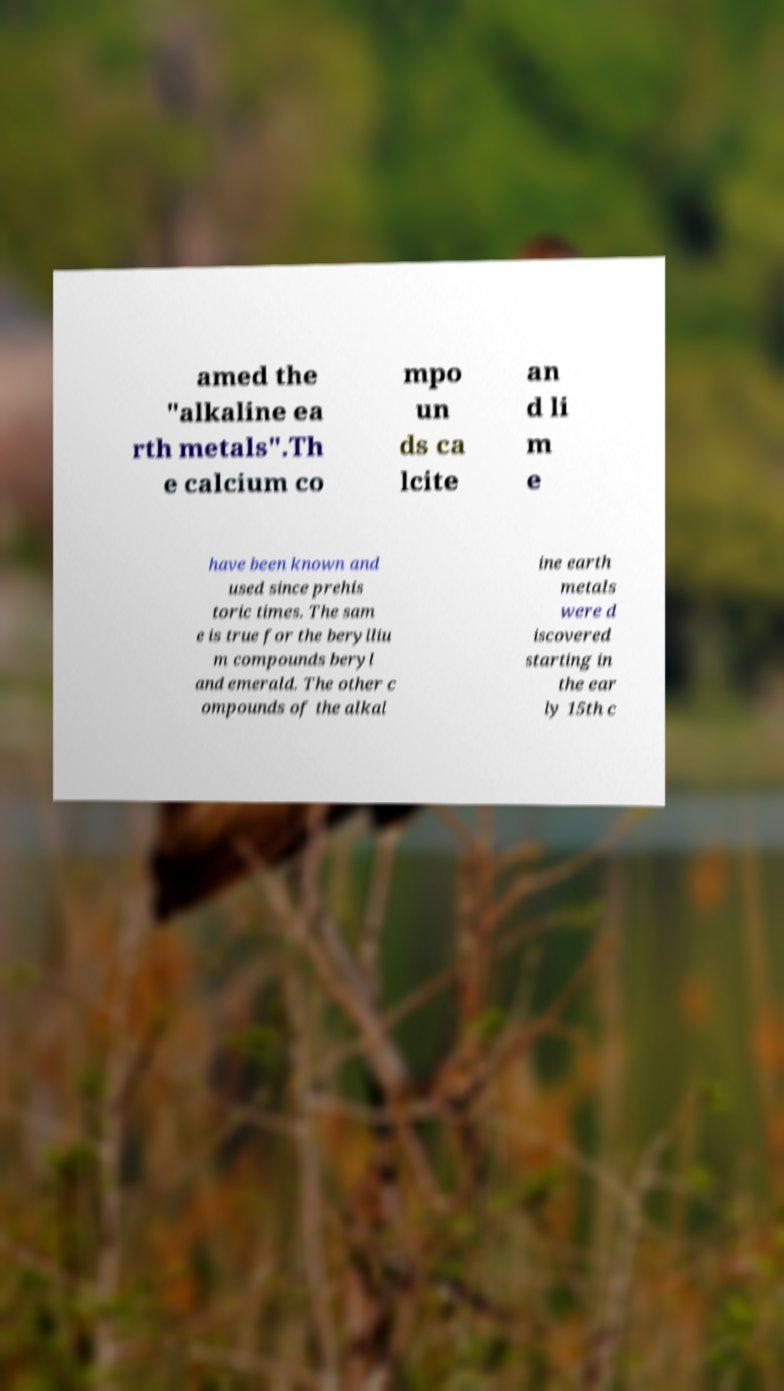For documentation purposes, I need the text within this image transcribed. Could you provide that? amed the "alkaline ea rth metals".Th e calcium co mpo un ds ca lcite an d li m e have been known and used since prehis toric times. The sam e is true for the berylliu m compounds beryl and emerald. The other c ompounds of the alkal ine earth metals were d iscovered starting in the ear ly 15th c 